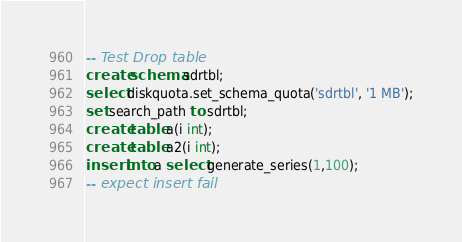Convert code to text. <code><loc_0><loc_0><loc_500><loc_500><_SQL_>-- Test Drop table
create schema sdrtbl;
select diskquota.set_schema_quota('sdrtbl', '1 MB');
set search_path to sdrtbl;
create table a(i int);
create table a2(i int);
insert into a select generate_series(1,100);
-- expect insert fail</code> 